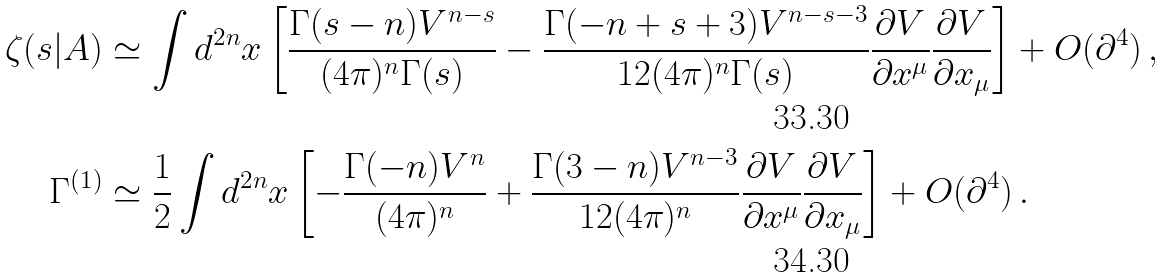<formula> <loc_0><loc_0><loc_500><loc_500>\zeta ( s | A ) & \simeq \int d ^ { 2 n } x \left [ \frac { \Gamma ( s - n ) V ^ { n - s } } { ( 4 \pi ) ^ { n } \Gamma ( s ) } - \frac { \Gamma ( - n + s + 3 ) V ^ { n - s - 3 } } { 1 2 ( 4 \pi ) ^ { n } \Gamma ( s ) } \frac { \partial V } { \partial x ^ { \mu } } \frac { \partial V } { \partial x _ { \mu } } \right ] + O ( \partial ^ { 4 } ) \, , \\ \Gamma ^ { ( 1 ) } & \simeq \frac { 1 } { 2 } \int d ^ { 2 n } x \left [ - \frac { \Gamma ( - n ) V ^ { n } } { ( 4 \pi ) ^ { n } } + \frac { \Gamma ( 3 - n ) V ^ { n - 3 } } { 1 2 ( 4 \pi ) ^ { n } } \frac { \partial V } { \partial x ^ { \mu } } \frac { \partial V } { \partial x _ { \mu } } \right ] + O ( \partial ^ { 4 } ) \, .</formula> 